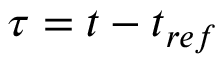Convert formula to latex. <formula><loc_0><loc_0><loc_500><loc_500>\tau = t - t _ { r e f }</formula> 